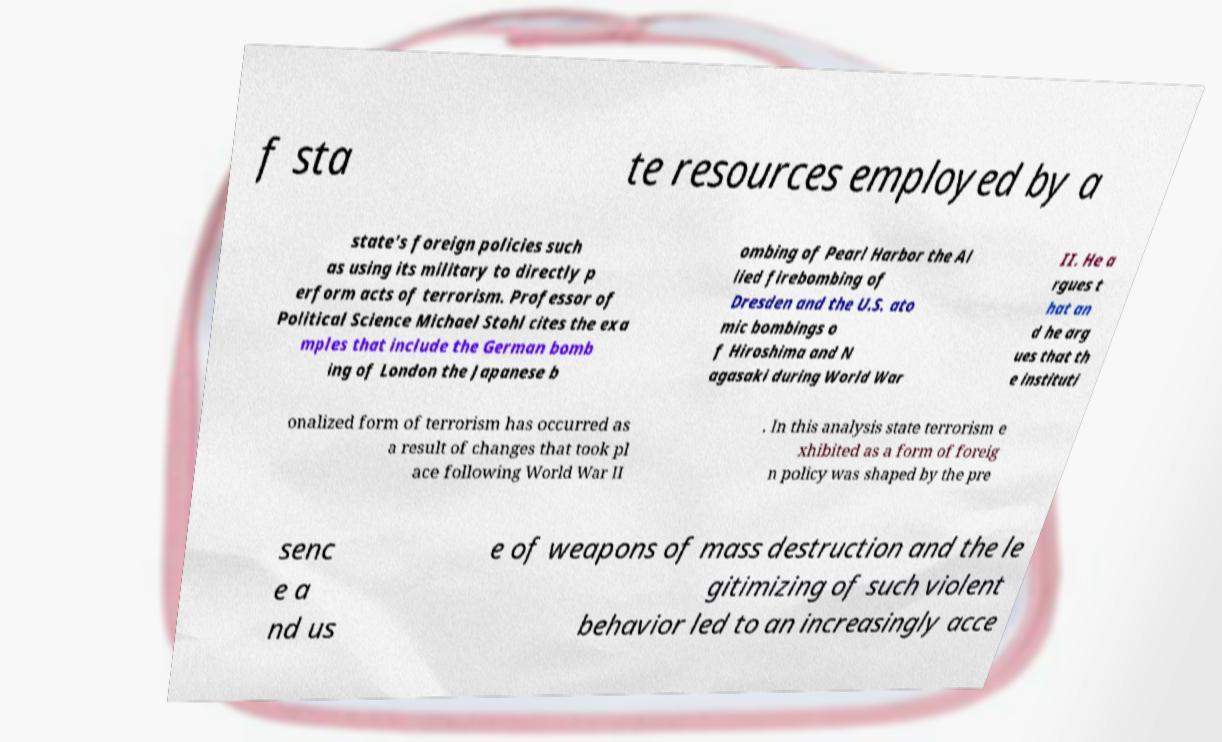Could you assist in decoding the text presented in this image and type it out clearly? f sta te resources employed by a state's foreign policies such as using its military to directly p erform acts of terrorism. Professor of Political Science Michael Stohl cites the exa mples that include the German bomb ing of London the Japanese b ombing of Pearl Harbor the Al lied firebombing of Dresden and the U.S. ato mic bombings o f Hiroshima and N agasaki during World War II. He a rgues t hat an d he arg ues that th e instituti onalized form of terrorism has occurred as a result of changes that took pl ace following World War II . In this analysis state terrorism e xhibited as a form of foreig n policy was shaped by the pre senc e a nd us e of weapons of mass destruction and the le gitimizing of such violent behavior led to an increasingly acce 